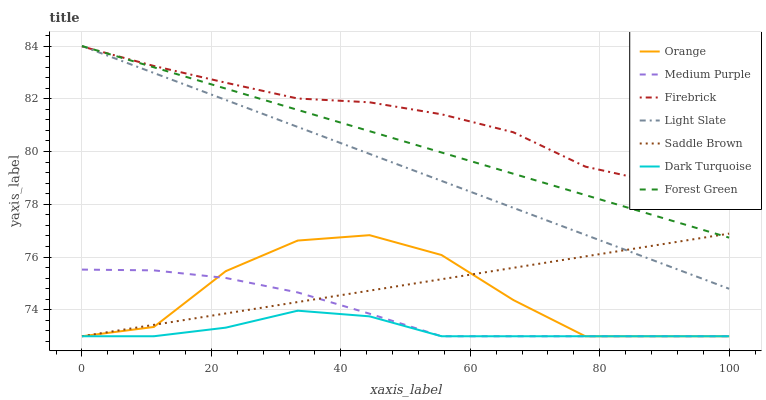Does Dark Turquoise have the minimum area under the curve?
Answer yes or no. Yes. Does Firebrick have the maximum area under the curve?
Answer yes or no. Yes. Does Firebrick have the minimum area under the curve?
Answer yes or no. No. Does Dark Turquoise have the maximum area under the curve?
Answer yes or no. No. Is Saddle Brown the smoothest?
Answer yes or no. Yes. Is Orange the roughest?
Answer yes or no. Yes. Is Dark Turquoise the smoothest?
Answer yes or no. No. Is Dark Turquoise the roughest?
Answer yes or no. No. Does Firebrick have the lowest value?
Answer yes or no. No. Does Forest Green have the highest value?
Answer yes or no. Yes. Does Firebrick have the highest value?
Answer yes or no. No. Is Saddle Brown less than Firebrick?
Answer yes or no. Yes. Is Light Slate greater than Medium Purple?
Answer yes or no. Yes. Does Dark Turquoise intersect Medium Purple?
Answer yes or no. Yes. Is Dark Turquoise less than Medium Purple?
Answer yes or no. No. Is Dark Turquoise greater than Medium Purple?
Answer yes or no. No. Does Saddle Brown intersect Firebrick?
Answer yes or no. No. 